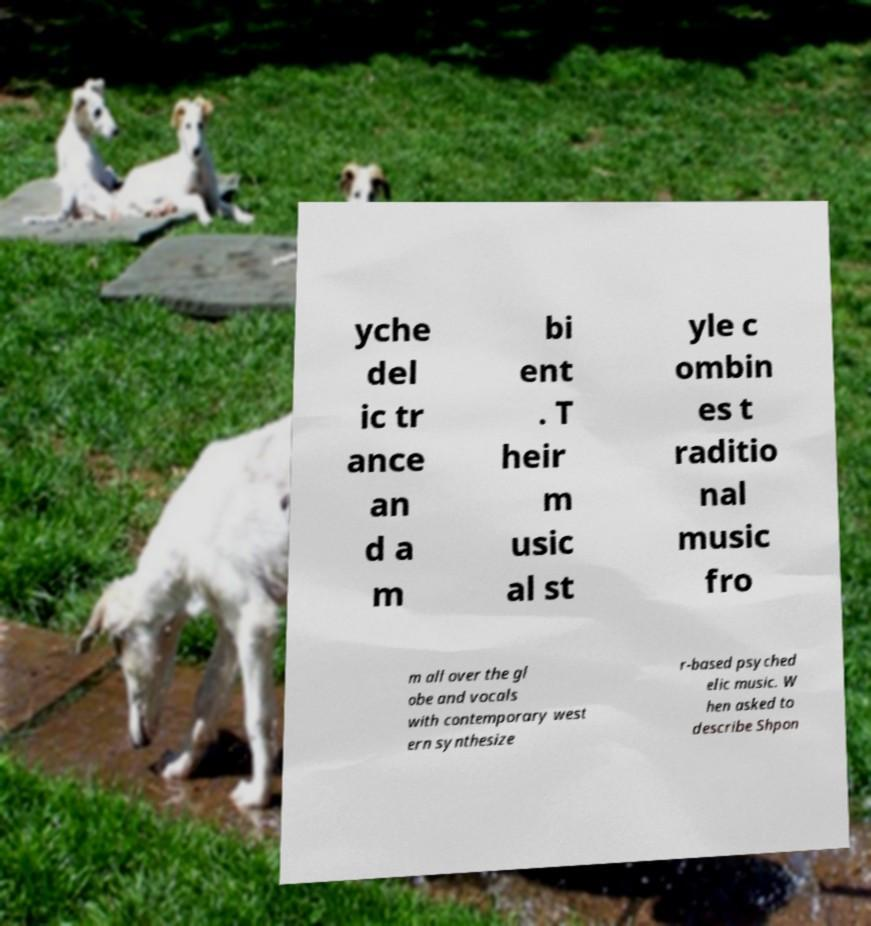What messages or text are displayed in this image? I need them in a readable, typed format. yche del ic tr ance an d a m bi ent . T heir m usic al st yle c ombin es t raditio nal music fro m all over the gl obe and vocals with contemporary west ern synthesize r-based psyched elic music. W hen asked to describe Shpon 